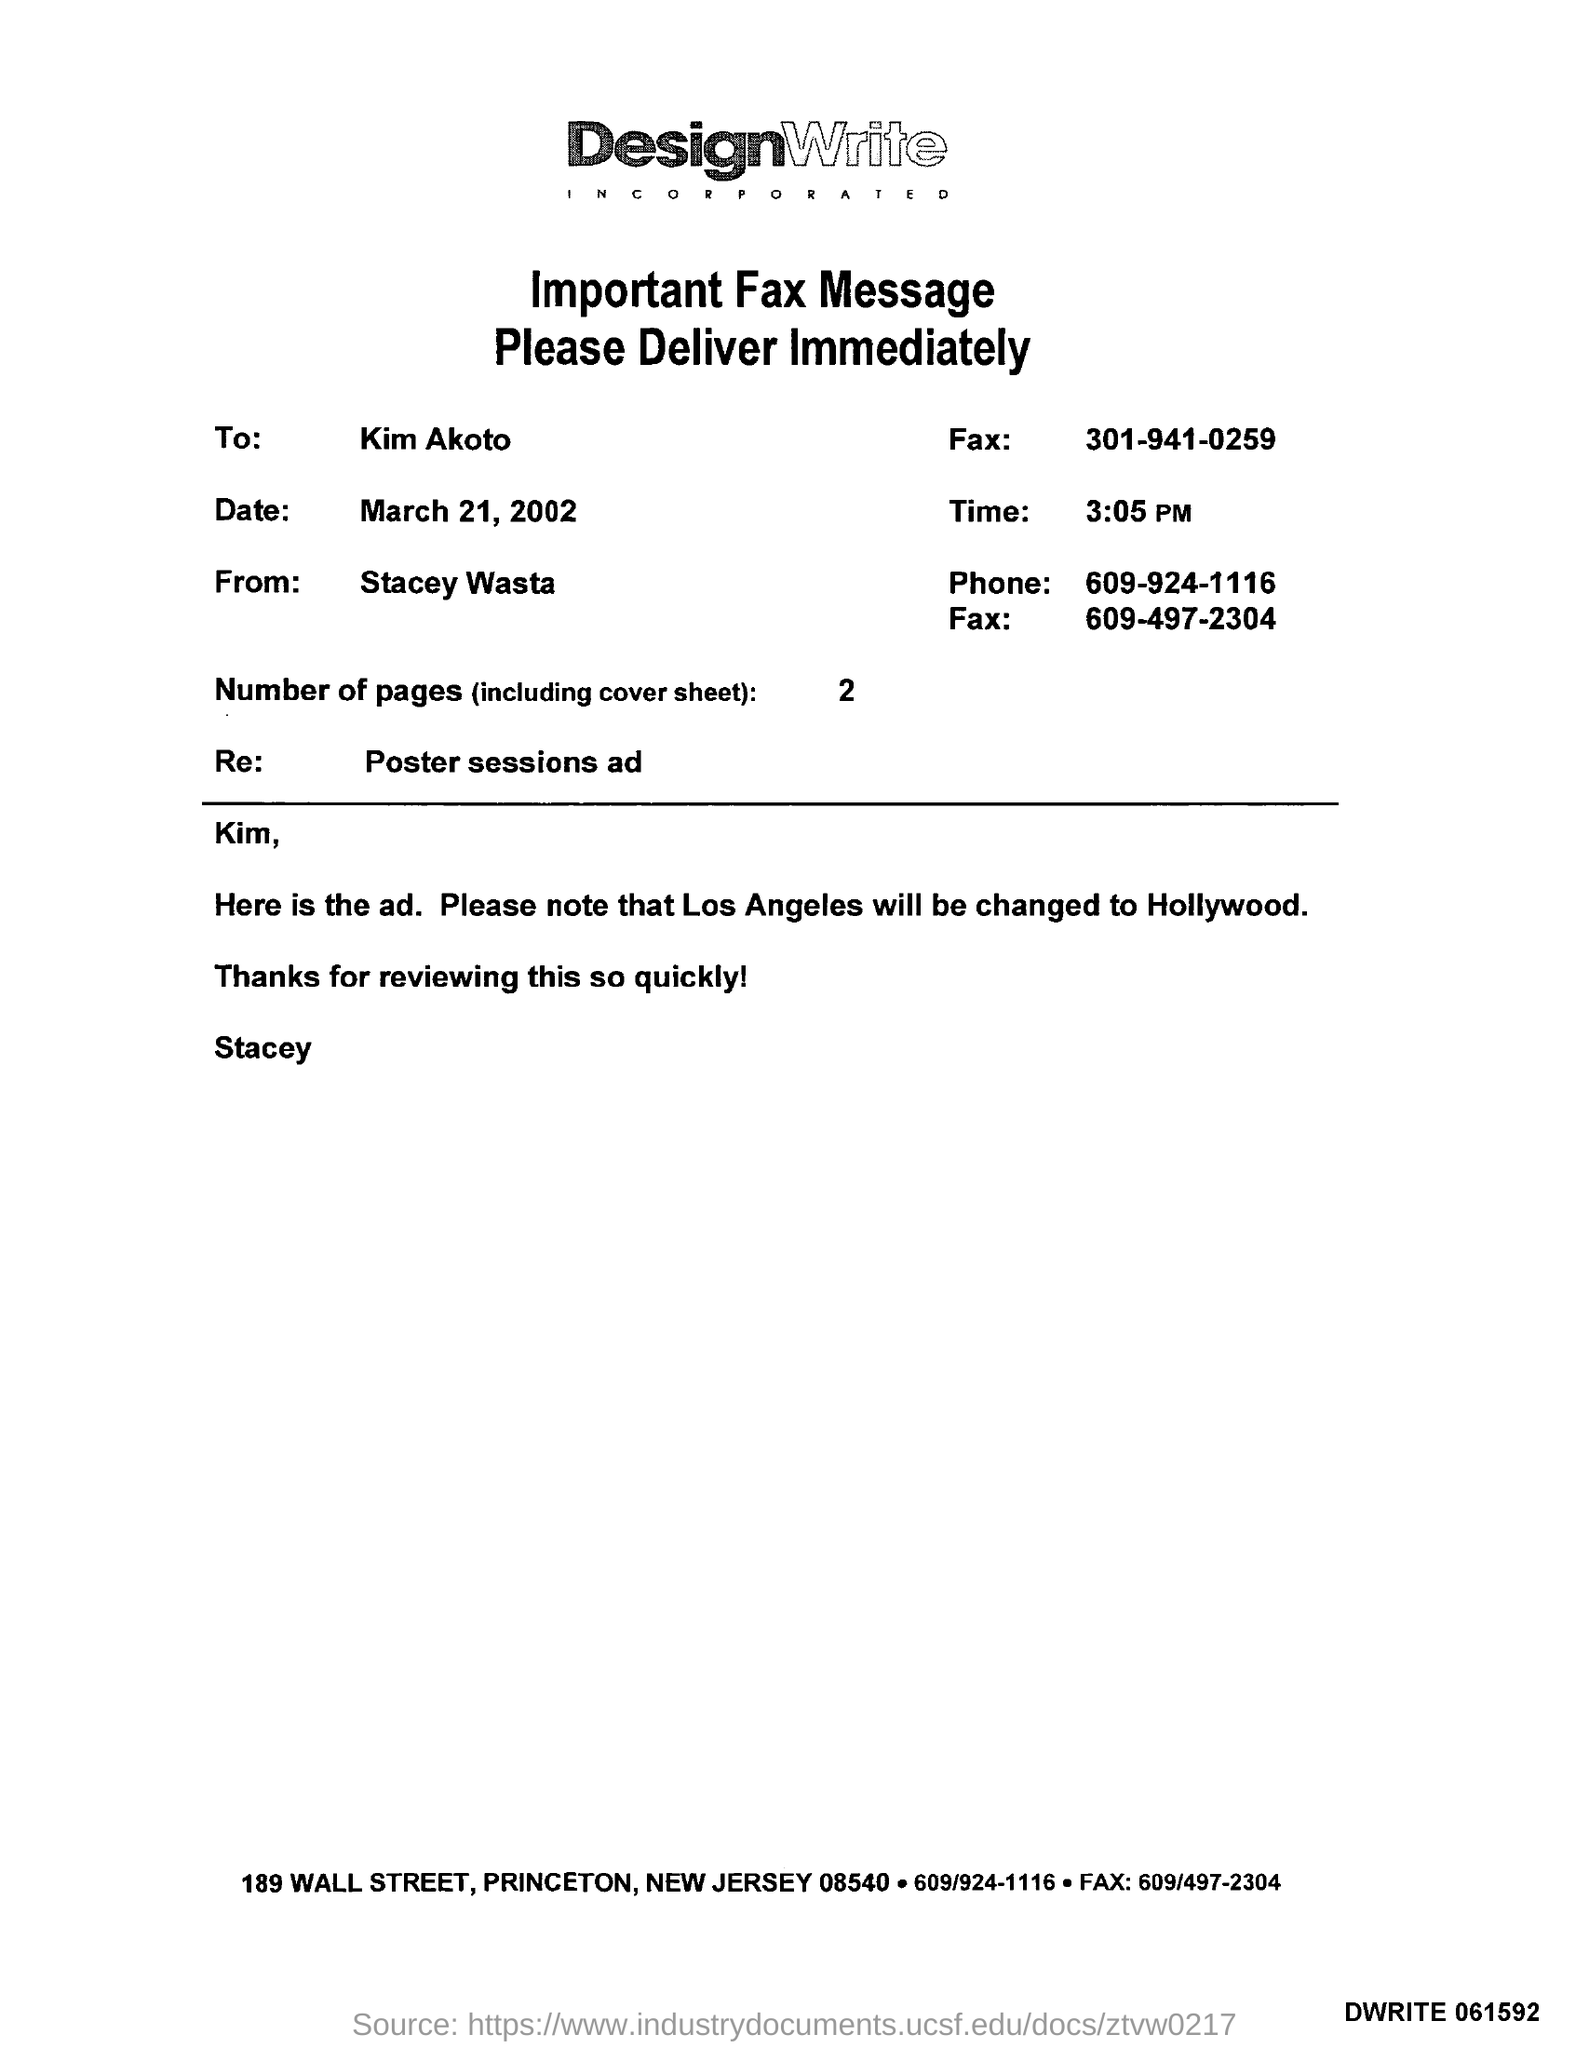To Whom is this Fax addressed to?
Give a very brief answer. Kim Akoto. Who is this Fax from?
Ensure brevity in your answer.  Stacey Wasta. What is the Date?
Ensure brevity in your answer.  March 21, 2002. What is the Time?
Your answer should be compact. 3:05 PM. What is the Phone?
Your response must be concise. 609-924-1116. What is the Re?
Your answer should be compact. Poster sessions ad. What are the Number of pages?
Your answer should be compact. 2. Los Angeles will be changed to what?
Your answer should be compact. Hollywood. 